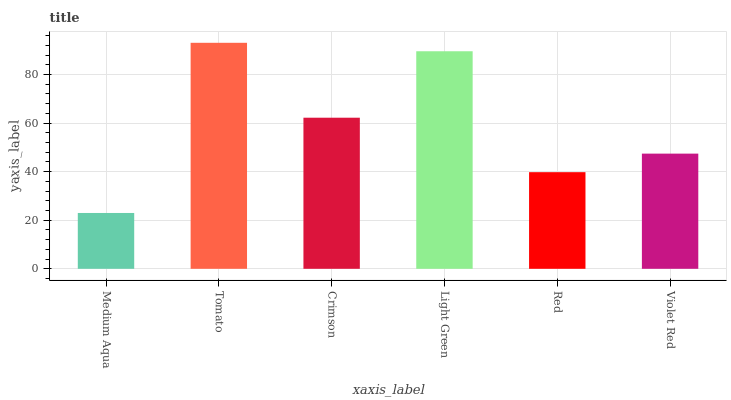Is Medium Aqua the minimum?
Answer yes or no. Yes. Is Tomato the maximum?
Answer yes or no. Yes. Is Crimson the minimum?
Answer yes or no. No. Is Crimson the maximum?
Answer yes or no. No. Is Tomato greater than Crimson?
Answer yes or no. Yes. Is Crimson less than Tomato?
Answer yes or no. Yes. Is Crimson greater than Tomato?
Answer yes or no. No. Is Tomato less than Crimson?
Answer yes or no. No. Is Crimson the high median?
Answer yes or no. Yes. Is Violet Red the low median?
Answer yes or no. Yes. Is Red the high median?
Answer yes or no. No. Is Tomato the low median?
Answer yes or no. No. 